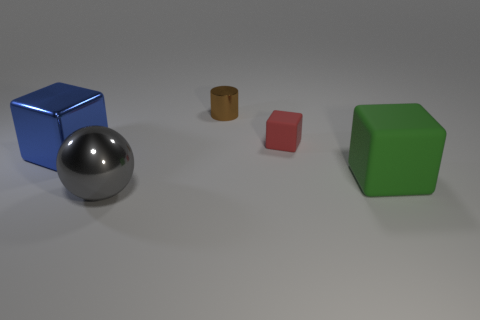How many metallic objects are both in front of the green rubber object and behind the gray thing?
Give a very brief answer. 0. How many other big rubber things are the same shape as the red matte thing?
Your response must be concise. 1. The big thing behind the block that is in front of the blue thing is what color?
Your answer should be compact. Blue. Is the shape of the tiny red object the same as the large object that is behind the large matte object?
Offer a terse response. Yes. There is a large block that is to the right of the large gray metallic sphere on the left side of the cube that is right of the small block; what is its material?
Make the answer very short. Rubber. Are there any cyan cylinders of the same size as the gray metallic thing?
Your answer should be compact. No. The thing that is the same material as the tiny red block is what size?
Give a very brief answer. Large. There is a blue shiny thing; what shape is it?
Offer a very short reply. Cube. Is the brown cylinder made of the same material as the block that is on the left side of the small metallic object?
Your answer should be very brief. Yes. How many things are either small red things or tiny brown things?
Your answer should be very brief. 2. 